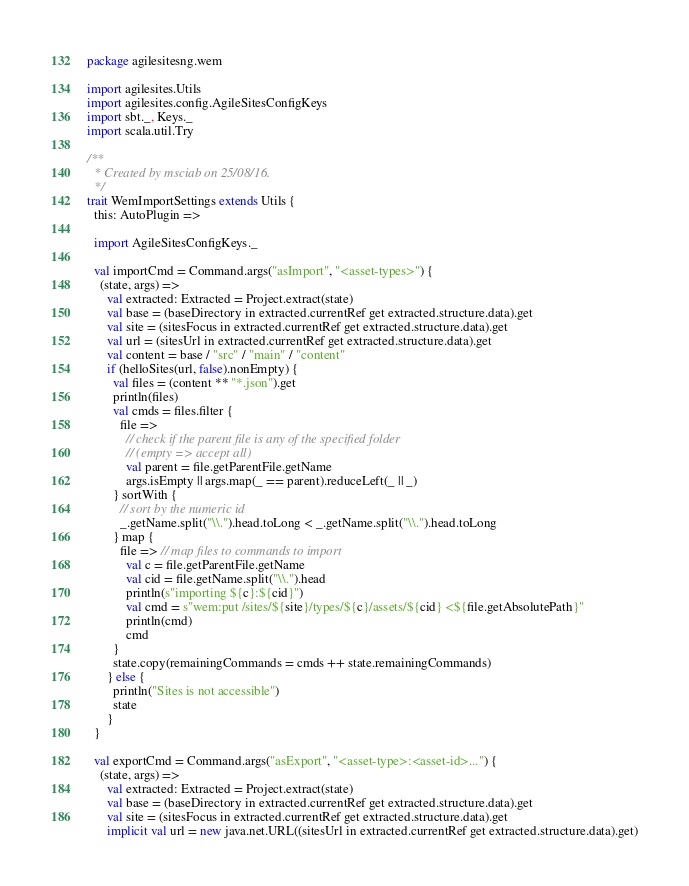<code> <loc_0><loc_0><loc_500><loc_500><_Scala_>package agilesitesng.wem

import agilesites.Utils
import agilesites.config.AgileSitesConfigKeys
import sbt._, Keys._
import scala.util.Try

/**
  * Created by msciab on 25/08/16.
  */
trait WemImportSettings extends Utils {
  this: AutoPlugin =>

  import AgileSitesConfigKeys._

  val importCmd = Command.args("asImport", "<asset-types>") {
    (state, args) =>
      val extracted: Extracted = Project.extract(state)
      val base = (baseDirectory in extracted.currentRef get extracted.structure.data).get
      val site = (sitesFocus in extracted.currentRef get extracted.structure.data).get
      val url = (sitesUrl in extracted.currentRef get extracted.structure.data).get
      val content = base / "src" / "main" / "content"
      if (helloSites(url, false).nonEmpty) {
        val files = (content ** "*.json").get
        println(files)
        val cmds = files.filter {
          file =>
            // check if the parent file is any of the specified folder
            // (empty => accept all)
            val parent = file.getParentFile.getName
            args.isEmpty || args.map(_ == parent).reduceLeft(_ || _)
        } sortWith {
          // sort by the numeric id
          _.getName.split("\\.").head.toLong < _.getName.split("\\.").head.toLong
        } map {
          file => // map files to commands to import
            val c = file.getParentFile.getName
            val cid = file.getName.split("\\.").head
            println(s"importing ${c}:${cid}")
            val cmd = s"wem:put /sites/${site}/types/${c}/assets/${cid} <${file.getAbsolutePath}"
            println(cmd)
            cmd
        }
        state.copy(remainingCommands = cmds ++ state.remainingCommands)
      } else {
        println("Sites is not accessible")
        state
      }
  }

  val exportCmd = Command.args("asExport", "<asset-type>:<asset-id>...") {
    (state, args) =>
      val extracted: Extracted = Project.extract(state)
      val base = (baseDirectory in extracted.currentRef get extracted.structure.data).get
      val site = (sitesFocus in extracted.currentRef get extracted.structure.data).get
      implicit val url = new java.net.URL((sitesUrl in extracted.currentRef get extracted.structure.data).get)</code> 